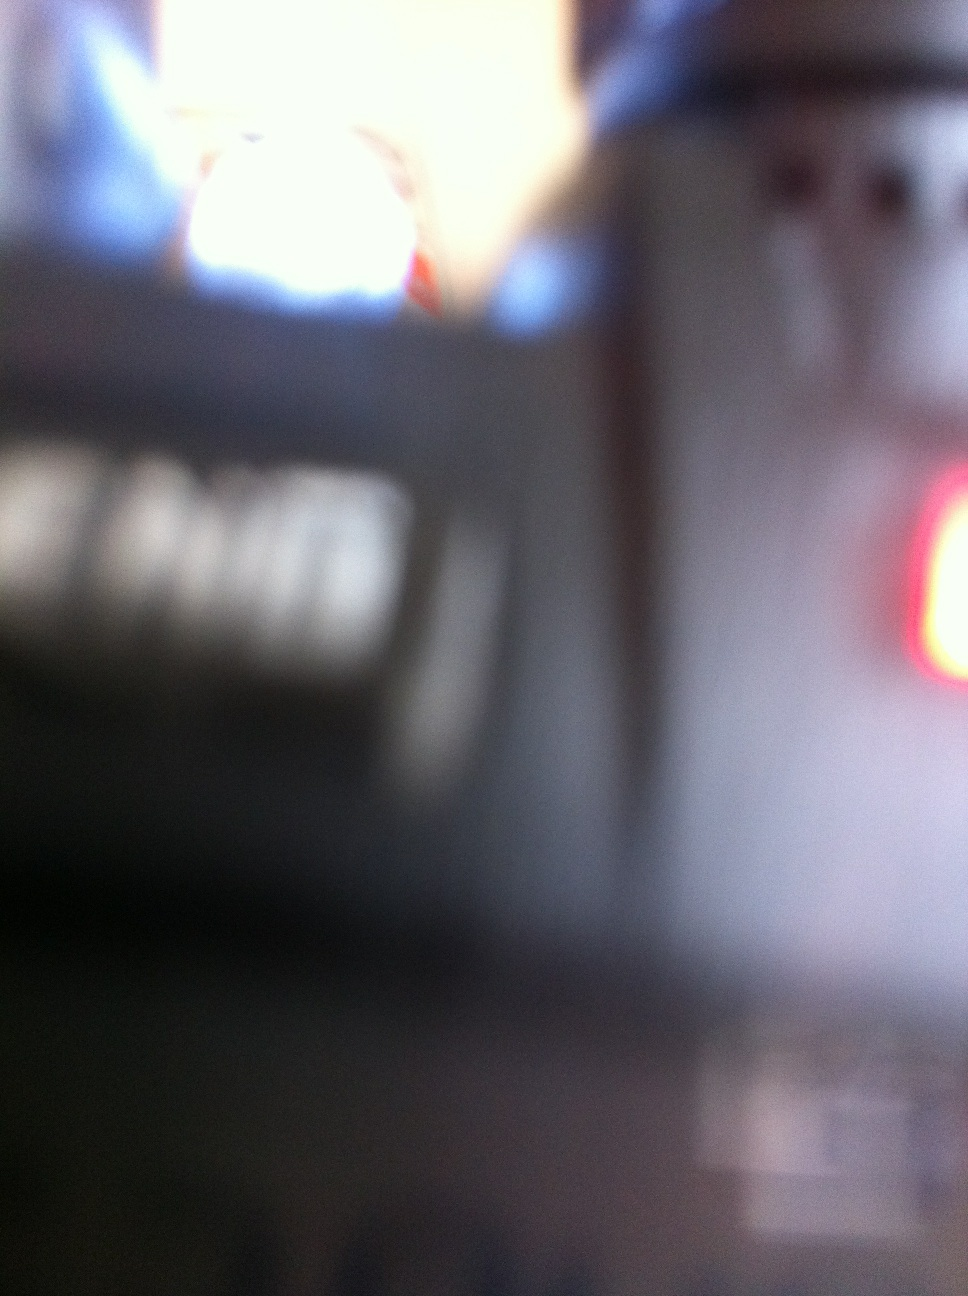Is there anything displayed on the display on the hand held radio, on the screen? Due to the blurriness of the provided image, it's not possible to accurately determine if there's any information displayed on the radio's screen. In clearer conditions, an analysis might involve looking for visible text or symbols that could indicate its operational status or settings. 